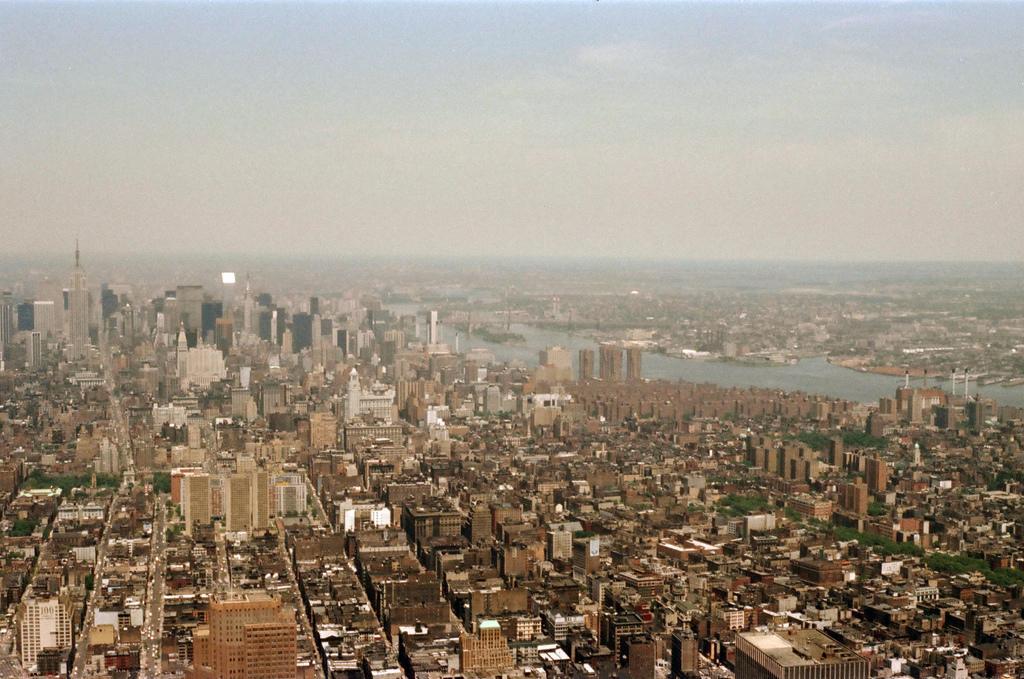Could you give a brief overview of what you see in this image? In this image I can see buildings, towers, trees, water and the sky. This image is taken may be during a day. 